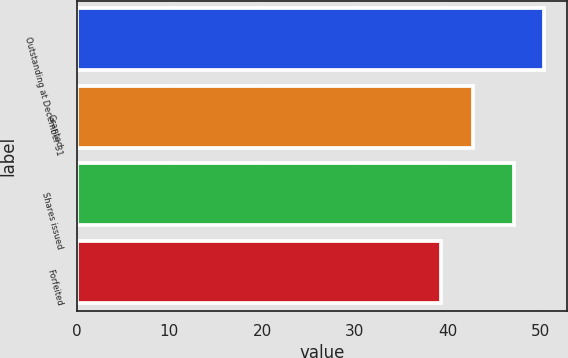<chart> <loc_0><loc_0><loc_500><loc_500><bar_chart><fcel>Outstanding at December 31<fcel>Granted<fcel>Shares issued<fcel>Forfeited<nl><fcel>50.4<fcel>42.81<fcel>47.14<fcel>39.36<nl></chart> 